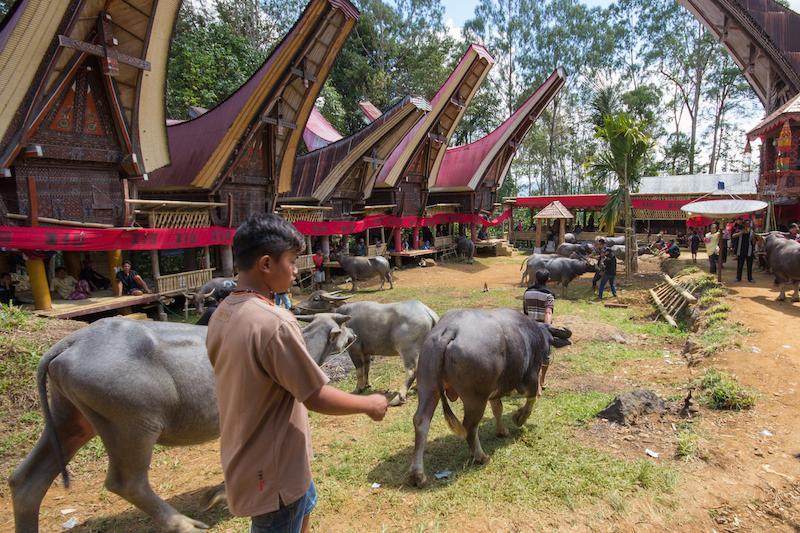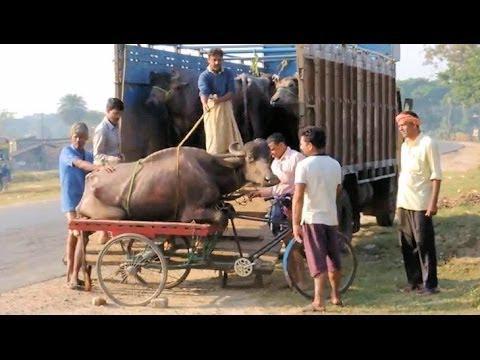The first image is the image on the left, the second image is the image on the right. Evaluate the accuracy of this statement regarding the images: "An image shows at least one person walking rightward with at least one ox that is not hitched to any wagon.". Is it true? Answer yes or no. Yes. 